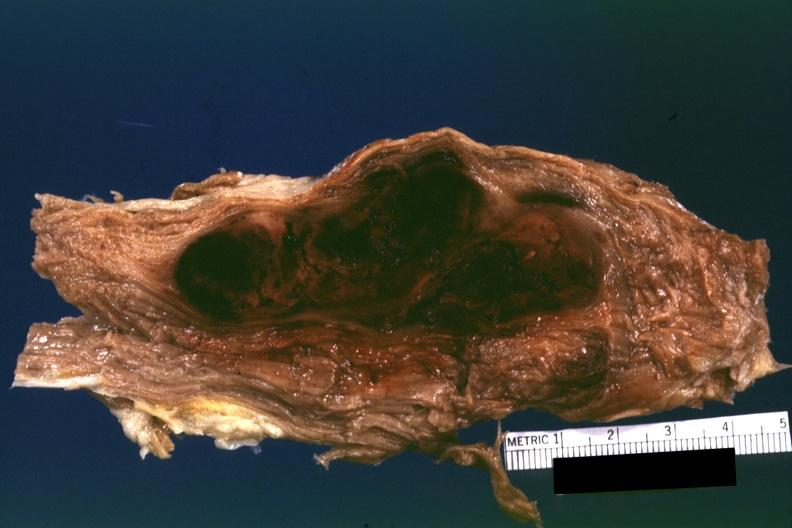s autopsy present?
Answer the question using a single word or phrase. No 